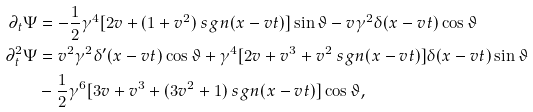<formula> <loc_0><loc_0><loc_500><loc_500>\partial _ { t } \Psi & = - { \frac { 1 } { 2 } } \gamma ^ { 4 } [ 2 v + ( 1 + v ^ { 2 } ) \ s g n ( x - v t ) ] \sin \vartheta - v \gamma ^ { 2 } \delta ( x - v t ) \cos \vartheta \\ \partial _ { t } ^ { 2 } \Psi & = v ^ { 2 } \gamma ^ { 2 } \delta ^ { \prime } ( x - v t ) \cos \vartheta + \gamma ^ { 4 } [ 2 v + v ^ { 3 } + v ^ { 2 } \ s g n ( x - v t ) ] \delta ( x - v t ) \sin \vartheta \\ & - { \frac { 1 } { 2 } } \gamma ^ { 6 } [ 3 v + v ^ { 3 } + ( 3 v ^ { 2 } + 1 ) \ s g n ( x - v t ) ] \cos \vartheta ,</formula> 